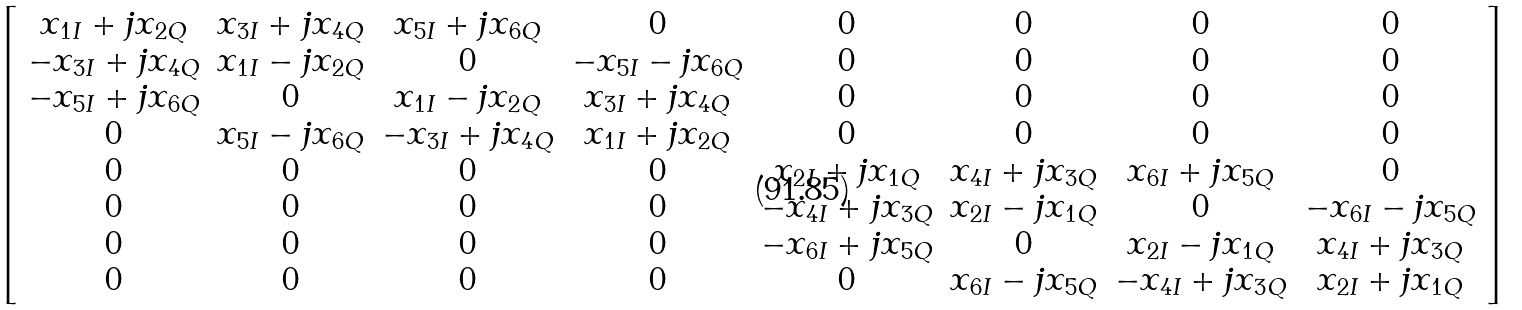<formula> <loc_0><loc_0><loc_500><loc_500>\left [ \begin{array} { c c c c c c c c } x _ { 1 I } + j x _ { 2 Q } & x _ { 3 I } + j x _ { 4 Q } & x _ { 5 I } + j x _ { 6 Q } & 0 & 0 & 0 & 0 & 0 \\ - x _ { 3 I } + j x _ { 4 Q } & x _ { 1 I } - j x _ { 2 Q } & 0 & - x _ { 5 I } - j x _ { 6 Q } & 0 & 0 & 0 & 0 \\ - x _ { 5 I } + j x _ { 6 Q } & 0 & x _ { 1 I } - j x _ { 2 Q } & x _ { 3 I } + j x _ { 4 Q } & 0 & 0 & 0 & 0 \\ 0 & x _ { 5 I } - j x _ { 6 Q } & - x _ { 3 I } + j x _ { 4 Q } & x _ { 1 I } + j x _ { 2 Q } & 0 & 0 & 0 & 0 \\ 0 & 0 & 0 & 0 & x _ { 2 I } + j x _ { 1 Q } & x _ { 4 I } + j x _ { 3 Q } & x _ { 6 I } + j x _ { 5 Q } & 0 \\ 0 & 0 & 0 & 0 & - x _ { 4 I } + j x _ { 3 Q } & x _ { 2 I } - j x _ { 1 Q } & 0 & - x _ { 6 I } - j x _ { 5 Q } \\ 0 & 0 & 0 & 0 & - x _ { 6 I } + j x _ { 5 Q } & 0 & x _ { 2 I } - j x _ { 1 Q } & x _ { 4 I } + j x _ { 3 Q } \\ 0 & 0 & 0 & 0 & 0 & x _ { 6 I } - j x _ { 5 Q } & - x _ { 4 I } + j x _ { 3 Q } & x _ { 2 I } + j x _ { 1 Q } \\ \end{array} \right ]</formula> 